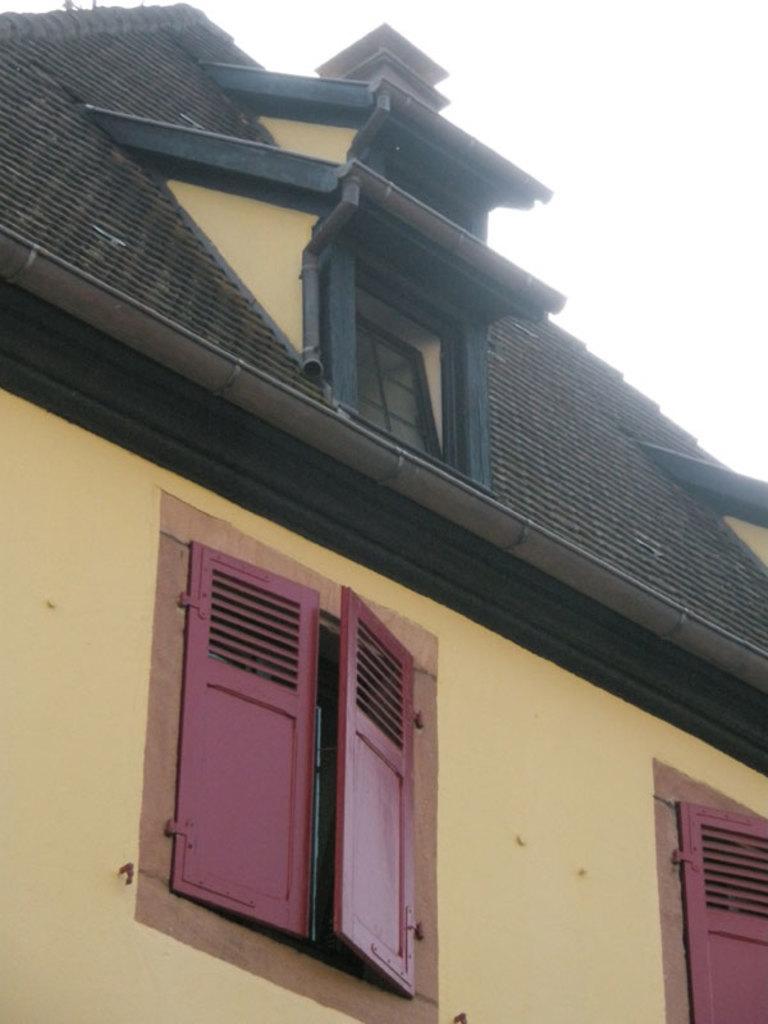Please provide a concise description of this image. In this image we can see yellow and black color house with pink color windows. 